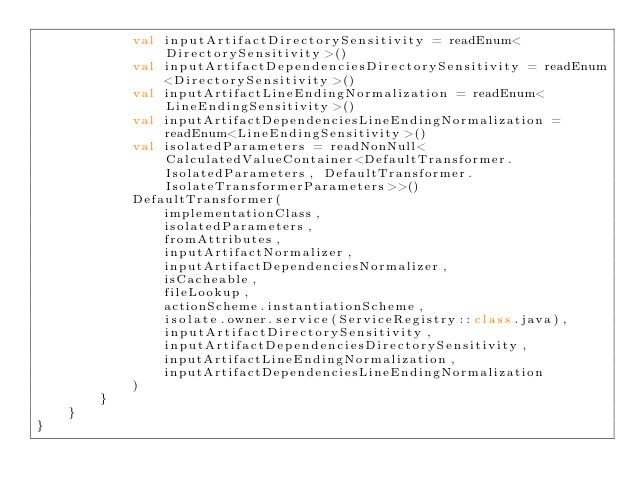Convert code to text. <code><loc_0><loc_0><loc_500><loc_500><_Kotlin_>            val inputArtifactDirectorySensitivity = readEnum<DirectorySensitivity>()
            val inputArtifactDependenciesDirectorySensitivity = readEnum<DirectorySensitivity>()
            val inputArtifactLineEndingNormalization = readEnum<LineEndingSensitivity>()
            val inputArtifactDependenciesLineEndingNormalization = readEnum<LineEndingSensitivity>()
            val isolatedParameters = readNonNull<CalculatedValueContainer<DefaultTransformer.IsolatedParameters, DefaultTransformer.IsolateTransformerParameters>>()
            DefaultTransformer(
                implementationClass,
                isolatedParameters,
                fromAttributes,
                inputArtifactNormalizer,
                inputArtifactDependenciesNormalizer,
                isCacheable,
                fileLookup,
                actionScheme.instantiationScheme,
                isolate.owner.service(ServiceRegistry::class.java),
                inputArtifactDirectorySensitivity,
                inputArtifactDependenciesDirectorySensitivity,
                inputArtifactLineEndingNormalization,
                inputArtifactDependenciesLineEndingNormalization
            )
        }
    }
}
</code> 